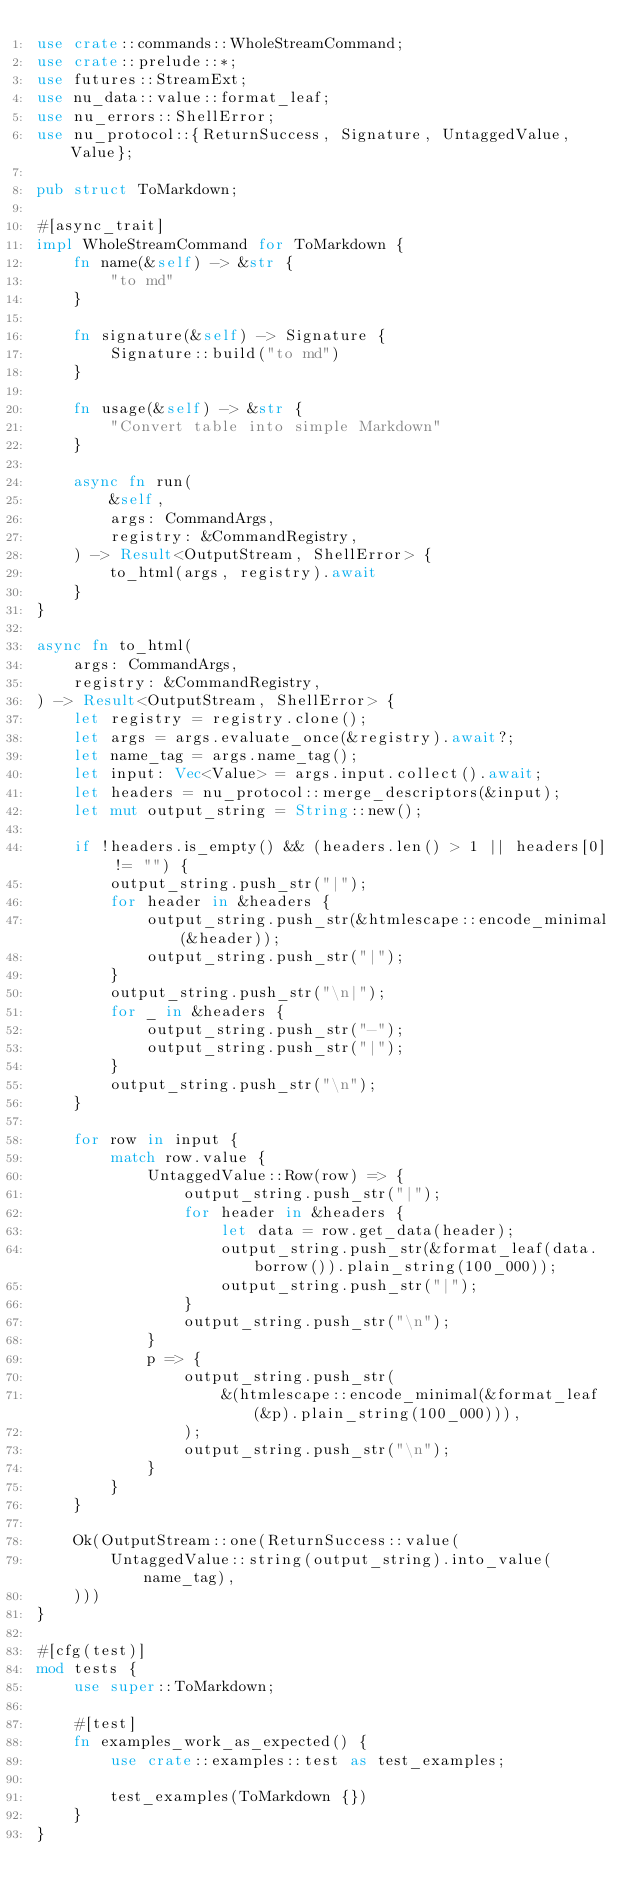<code> <loc_0><loc_0><loc_500><loc_500><_Rust_>use crate::commands::WholeStreamCommand;
use crate::prelude::*;
use futures::StreamExt;
use nu_data::value::format_leaf;
use nu_errors::ShellError;
use nu_protocol::{ReturnSuccess, Signature, UntaggedValue, Value};

pub struct ToMarkdown;

#[async_trait]
impl WholeStreamCommand for ToMarkdown {
    fn name(&self) -> &str {
        "to md"
    }

    fn signature(&self) -> Signature {
        Signature::build("to md")
    }

    fn usage(&self) -> &str {
        "Convert table into simple Markdown"
    }

    async fn run(
        &self,
        args: CommandArgs,
        registry: &CommandRegistry,
    ) -> Result<OutputStream, ShellError> {
        to_html(args, registry).await
    }
}

async fn to_html(
    args: CommandArgs,
    registry: &CommandRegistry,
) -> Result<OutputStream, ShellError> {
    let registry = registry.clone();
    let args = args.evaluate_once(&registry).await?;
    let name_tag = args.name_tag();
    let input: Vec<Value> = args.input.collect().await;
    let headers = nu_protocol::merge_descriptors(&input);
    let mut output_string = String::new();

    if !headers.is_empty() && (headers.len() > 1 || headers[0] != "") {
        output_string.push_str("|");
        for header in &headers {
            output_string.push_str(&htmlescape::encode_minimal(&header));
            output_string.push_str("|");
        }
        output_string.push_str("\n|");
        for _ in &headers {
            output_string.push_str("-");
            output_string.push_str("|");
        }
        output_string.push_str("\n");
    }

    for row in input {
        match row.value {
            UntaggedValue::Row(row) => {
                output_string.push_str("|");
                for header in &headers {
                    let data = row.get_data(header);
                    output_string.push_str(&format_leaf(data.borrow()).plain_string(100_000));
                    output_string.push_str("|");
                }
                output_string.push_str("\n");
            }
            p => {
                output_string.push_str(
                    &(htmlescape::encode_minimal(&format_leaf(&p).plain_string(100_000))),
                );
                output_string.push_str("\n");
            }
        }
    }

    Ok(OutputStream::one(ReturnSuccess::value(
        UntaggedValue::string(output_string).into_value(name_tag),
    )))
}

#[cfg(test)]
mod tests {
    use super::ToMarkdown;

    #[test]
    fn examples_work_as_expected() {
        use crate::examples::test as test_examples;

        test_examples(ToMarkdown {})
    }
}
</code> 